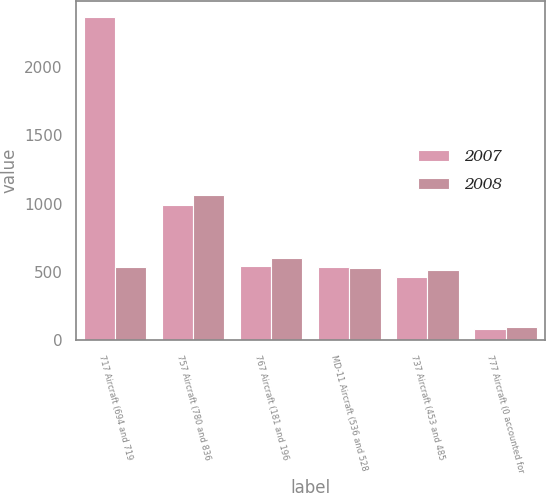Convert chart to OTSL. <chart><loc_0><loc_0><loc_500><loc_500><stacked_bar_chart><ecel><fcel>717 Aircraft (694 and 719<fcel>757 Aircraft (780 and 836<fcel>767 Aircraft (181 and 196<fcel>MD-11 Aircraft (536 and 528<fcel>737 Aircraft (453 and 485<fcel>777 Aircraft (0 accounted for<nl><fcel>2007<fcel>2365<fcel>991<fcel>540<fcel>536<fcel>464<fcel>81<nl><fcel>2008<fcel>536<fcel>1064<fcel>599<fcel>528<fcel>518<fcel>96<nl></chart> 